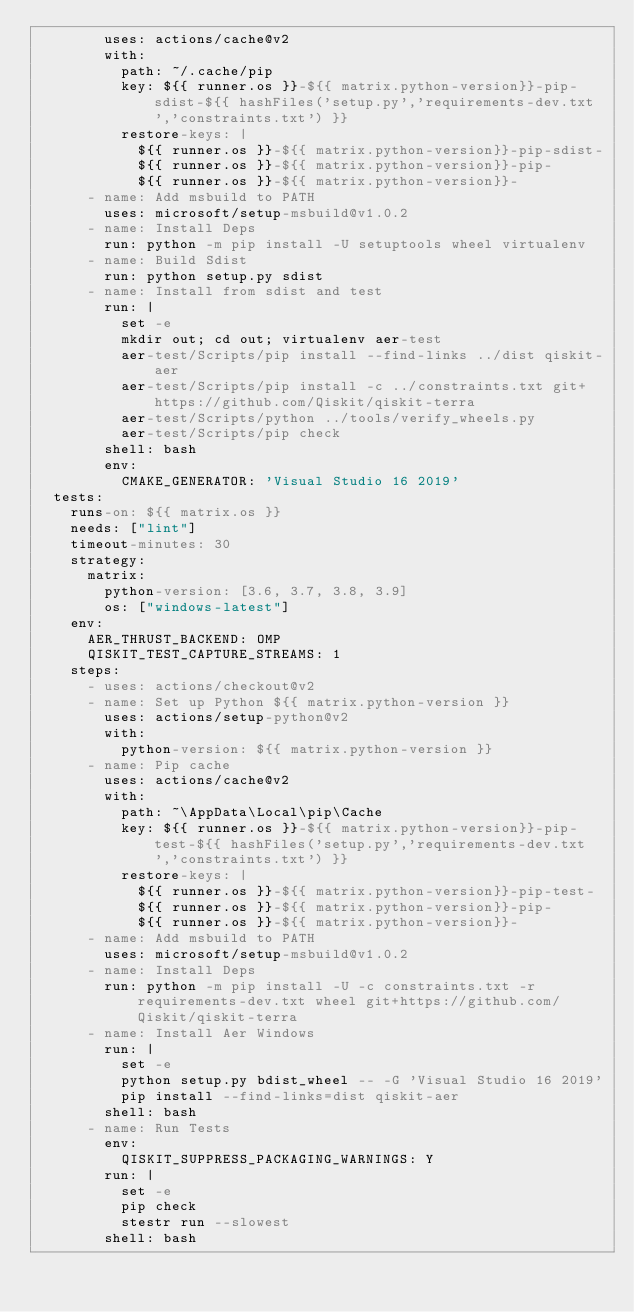<code> <loc_0><loc_0><loc_500><loc_500><_YAML_>        uses: actions/cache@v2
        with:
          path: ~/.cache/pip
          key: ${{ runner.os }}-${{ matrix.python-version}}-pip-sdist-${{ hashFiles('setup.py','requirements-dev.txt','constraints.txt') }}
          restore-keys: |
            ${{ runner.os }}-${{ matrix.python-version}}-pip-sdist-
            ${{ runner.os }}-${{ matrix.python-version}}-pip-
            ${{ runner.os }}-${{ matrix.python-version}}-
      - name: Add msbuild to PATH
        uses: microsoft/setup-msbuild@v1.0.2
      - name: Install Deps
        run: python -m pip install -U setuptools wheel virtualenv
      - name: Build Sdist
        run: python setup.py sdist
      - name: Install from sdist and test
        run: |
          set -e
          mkdir out; cd out; virtualenv aer-test
          aer-test/Scripts/pip install --find-links ../dist qiskit-aer
          aer-test/Scripts/pip install -c ../constraints.txt git+https://github.com/Qiskit/qiskit-terra
          aer-test/Scripts/python ../tools/verify_wheels.py
          aer-test/Scripts/pip check
        shell: bash
        env:
          CMAKE_GENERATOR: 'Visual Studio 16 2019'
  tests:
    runs-on: ${{ matrix.os }}
    needs: ["lint"]
    timeout-minutes: 30
    strategy:
      matrix:
        python-version: [3.6, 3.7, 3.8, 3.9]
        os: ["windows-latest"]
    env:
      AER_THRUST_BACKEND: OMP
      QISKIT_TEST_CAPTURE_STREAMS: 1
    steps:
      - uses: actions/checkout@v2
      - name: Set up Python ${{ matrix.python-version }}
        uses: actions/setup-python@v2
        with:
          python-version: ${{ matrix.python-version }}
      - name: Pip cache
        uses: actions/cache@v2
        with:
          path: ~\AppData\Local\pip\Cache
          key: ${{ runner.os }}-${{ matrix.python-version}}-pip-test-${{ hashFiles('setup.py','requirements-dev.txt','constraints.txt') }}
          restore-keys: |
            ${{ runner.os }}-${{ matrix.python-version}}-pip-test-
            ${{ runner.os }}-${{ matrix.python-version}}-pip-
            ${{ runner.os }}-${{ matrix.python-version}}-
      - name: Add msbuild to PATH
        uses: microsoft/setup-msbuild@v1.0.2
      - name: Install Deps
        run: python -m pip install -U -c constraints.txt -r requirements-dev.txt wheel git+https://github.com/Qiskit/qiskit-terra
      - name: Install Aer Windows
        run: |
          set -e
          python setup.py bdist_wheel -- -G 'Visual Studio 16 2019'
          pip install --find-links=dist qiskit-aer
        shell: bash
      - name: Run Tests
        env:
          QISKIT_SUPPRESS_PACKAGING_WARNINGS: Y
        run: |
          set -e
          pip check
          stestr run --slowest
        shell: bash
</code> 